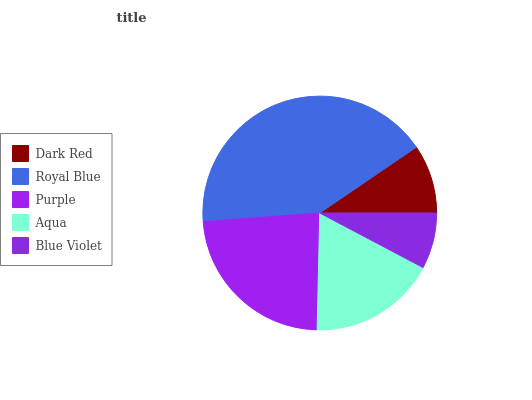Is Blue Violet the minimum?
Answer yes or no. Yes. Is Royal Blue the maximum?
Answer yes or no. Yes. Is Purple the minimum?
Answer yes or no. No. Is Purple the maximum?
Answer yes or no. No. Is Royal Blue greater than Purple?
Answer yes or no. Yes. Is Purple less than Royal Blue?
Answer yes or no. Yes. Is Purple greater than Royal Blue?
Answer yes or no. No. Is Royal Blue less than Purple?
Answer yes or no. No. Is Aqua the high median?
Answer yes or no. Yes. Is Aqua the low median?
Answer yes or no. Yes. Is Dark Red the high median?
Answer yes or no. No. Is Purple the low median?
Answer yes or no. No. 